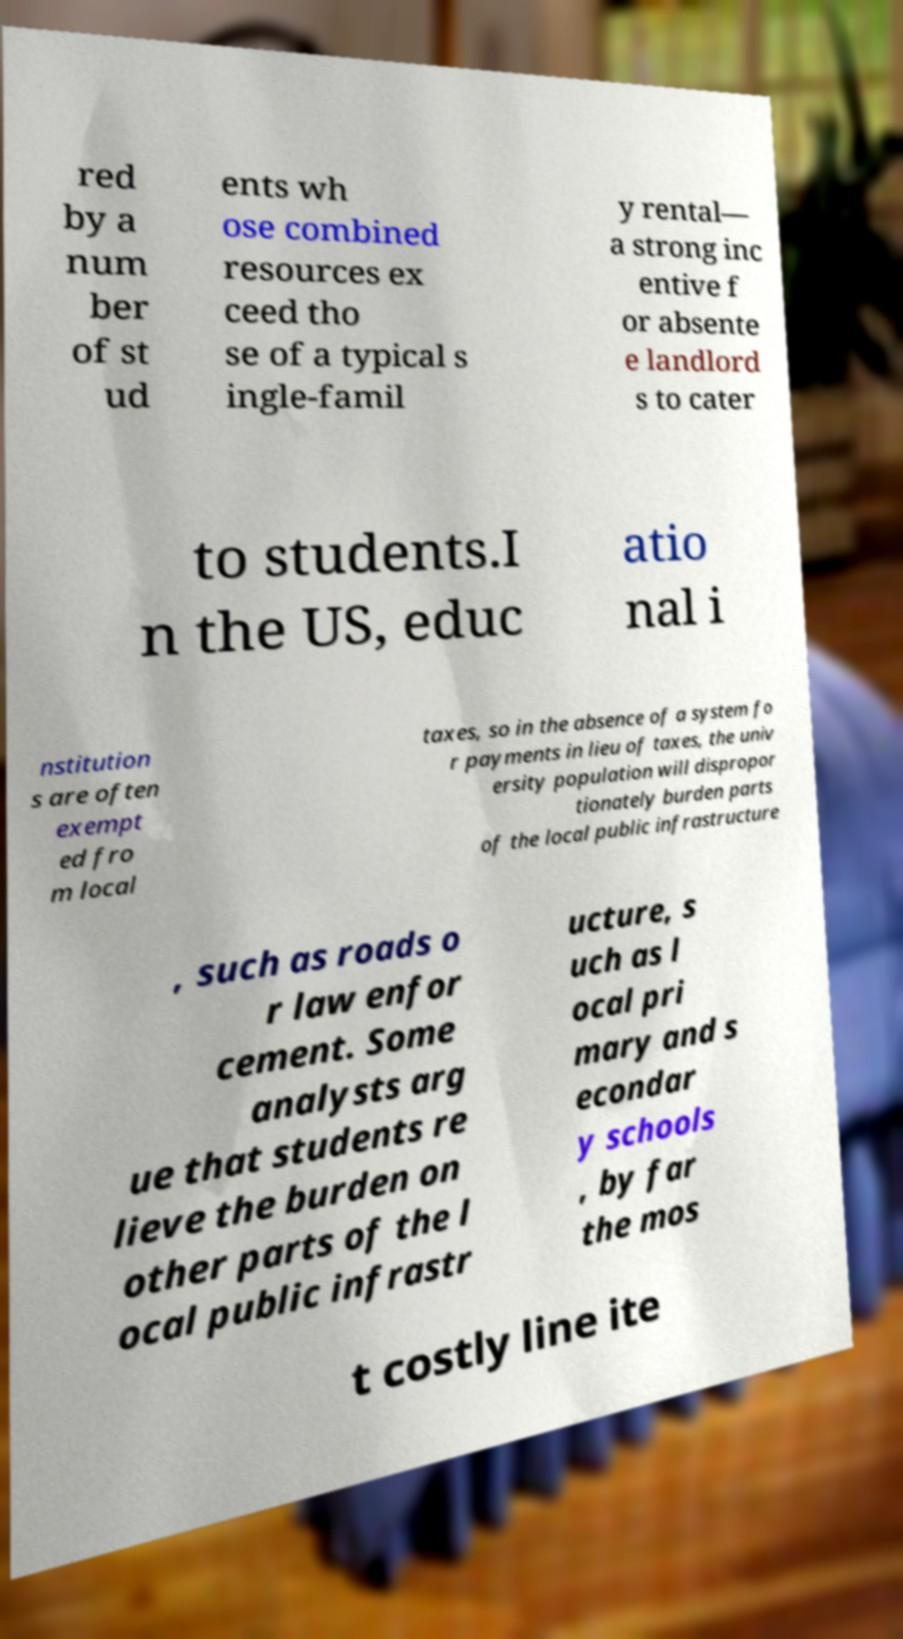For documentation purposes, I need the text within this image transcribed. Could you provide that? red by a num ber of st ud ents wh ose combined resources ex ceed tho se of a typical s ingle-famil y rental— a strong inc entive f or absente e landlord s to cater to students.I n the US, educ atio nal i nstitution s are often exempt ed fro m local taxes, so in the absence of a system fo r payments in lieu of taxes, the univ ersity population will dispropor tionately burden parts of the local public infrastructure , such as roads o r law enfor cement. Some analysts arg ue that students re lieve the burden on other parts of the l ocal public infrastr ucture, s uch as l ocal pri mary and s econdar y schools , by far the mos t costly line ite 